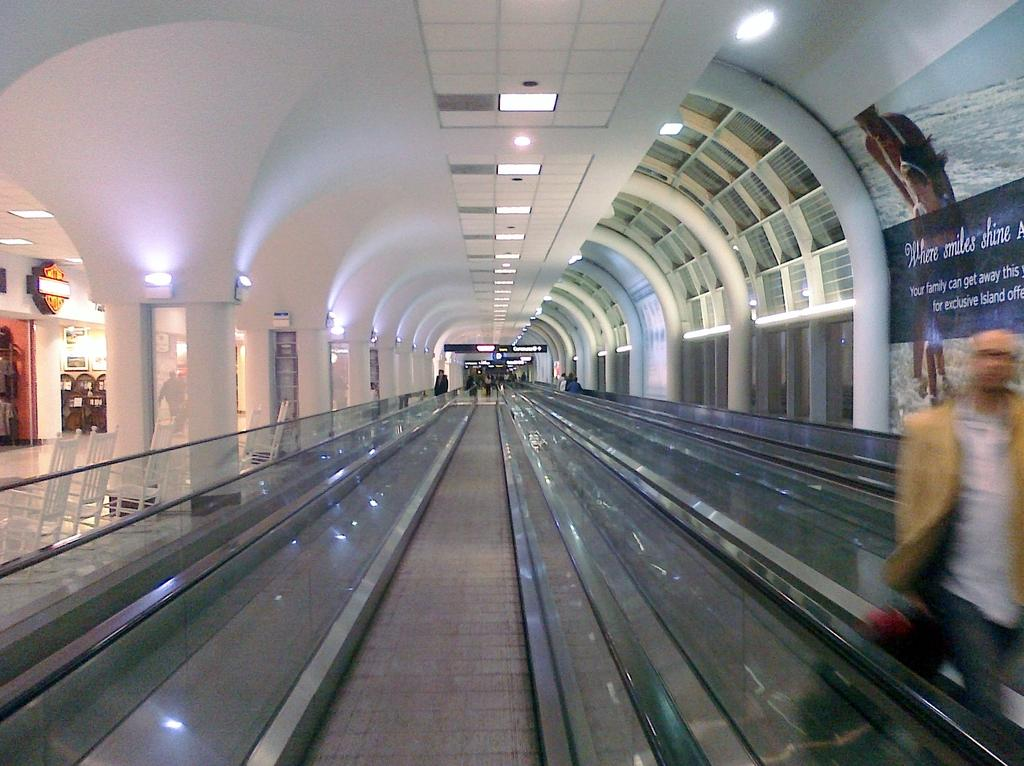<image>
Share a concise interpretation of the image provided. A "where smiles shine" ad is in the hallway. 